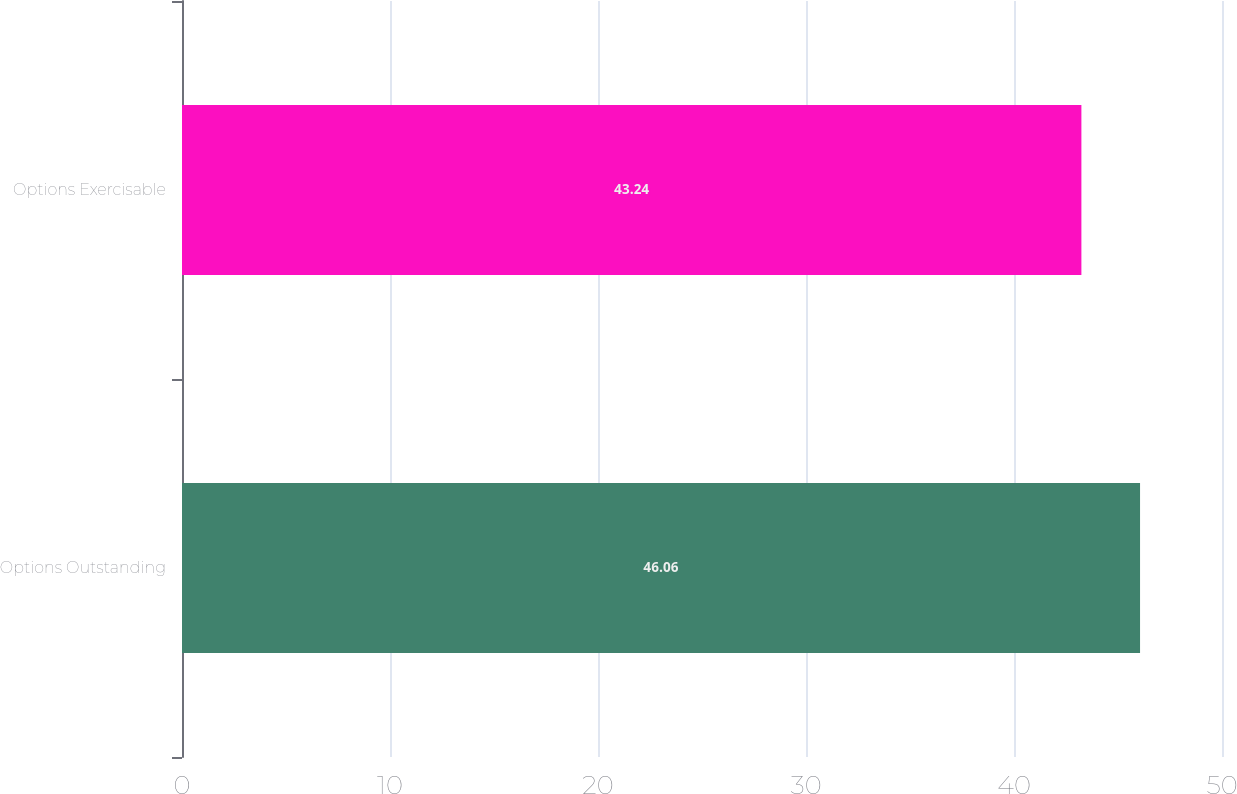Convert chart. <chart><loc_0><loc_0><loc_500><loc_500><bar_chart><fcel>Options Outstanding<fcel>Options Exercisable<nl><fcel>46.06<fcel>43.24<nl></chart> 